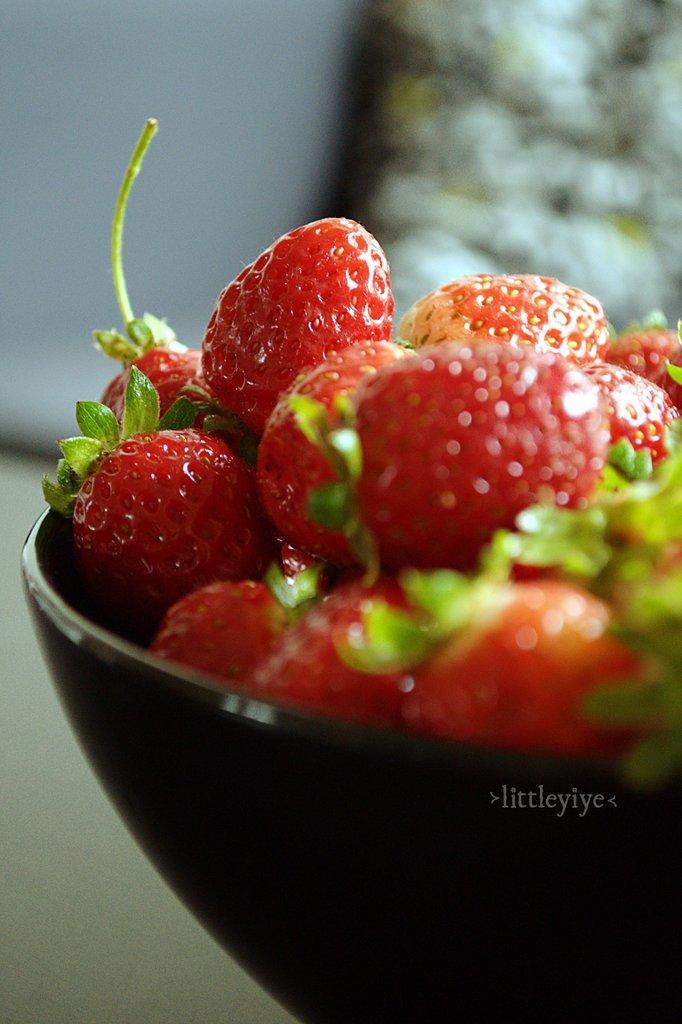Please provide a concise description of this image. In this picture, we can see a table, on that table there is a bowl, in the bowl there are some strawberries in it. In the background, we can see white color. 